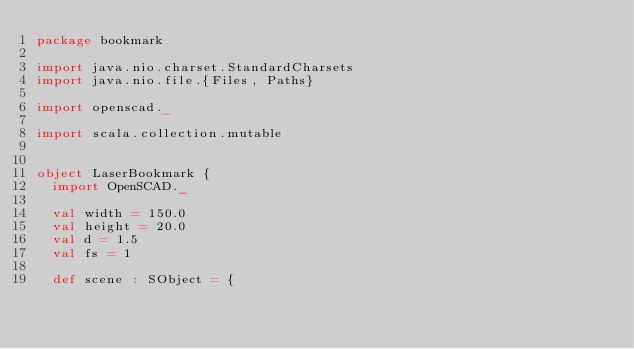Convert code to text. <code><loc_0><loc_0><loc_500><loc_500><_Scala_>package bookmark

import java.nio.charset.StandardCharsets
import java.nio.file.{Files, Paths}

import openscad._

import scala.collection.mutable


object LaserBookmark {
  import OpenSCAD._

  val width = 150.0
  val height = 20.0
  val d = 1.5
  val fs = 1

  def scene : SObject = {
</code> 